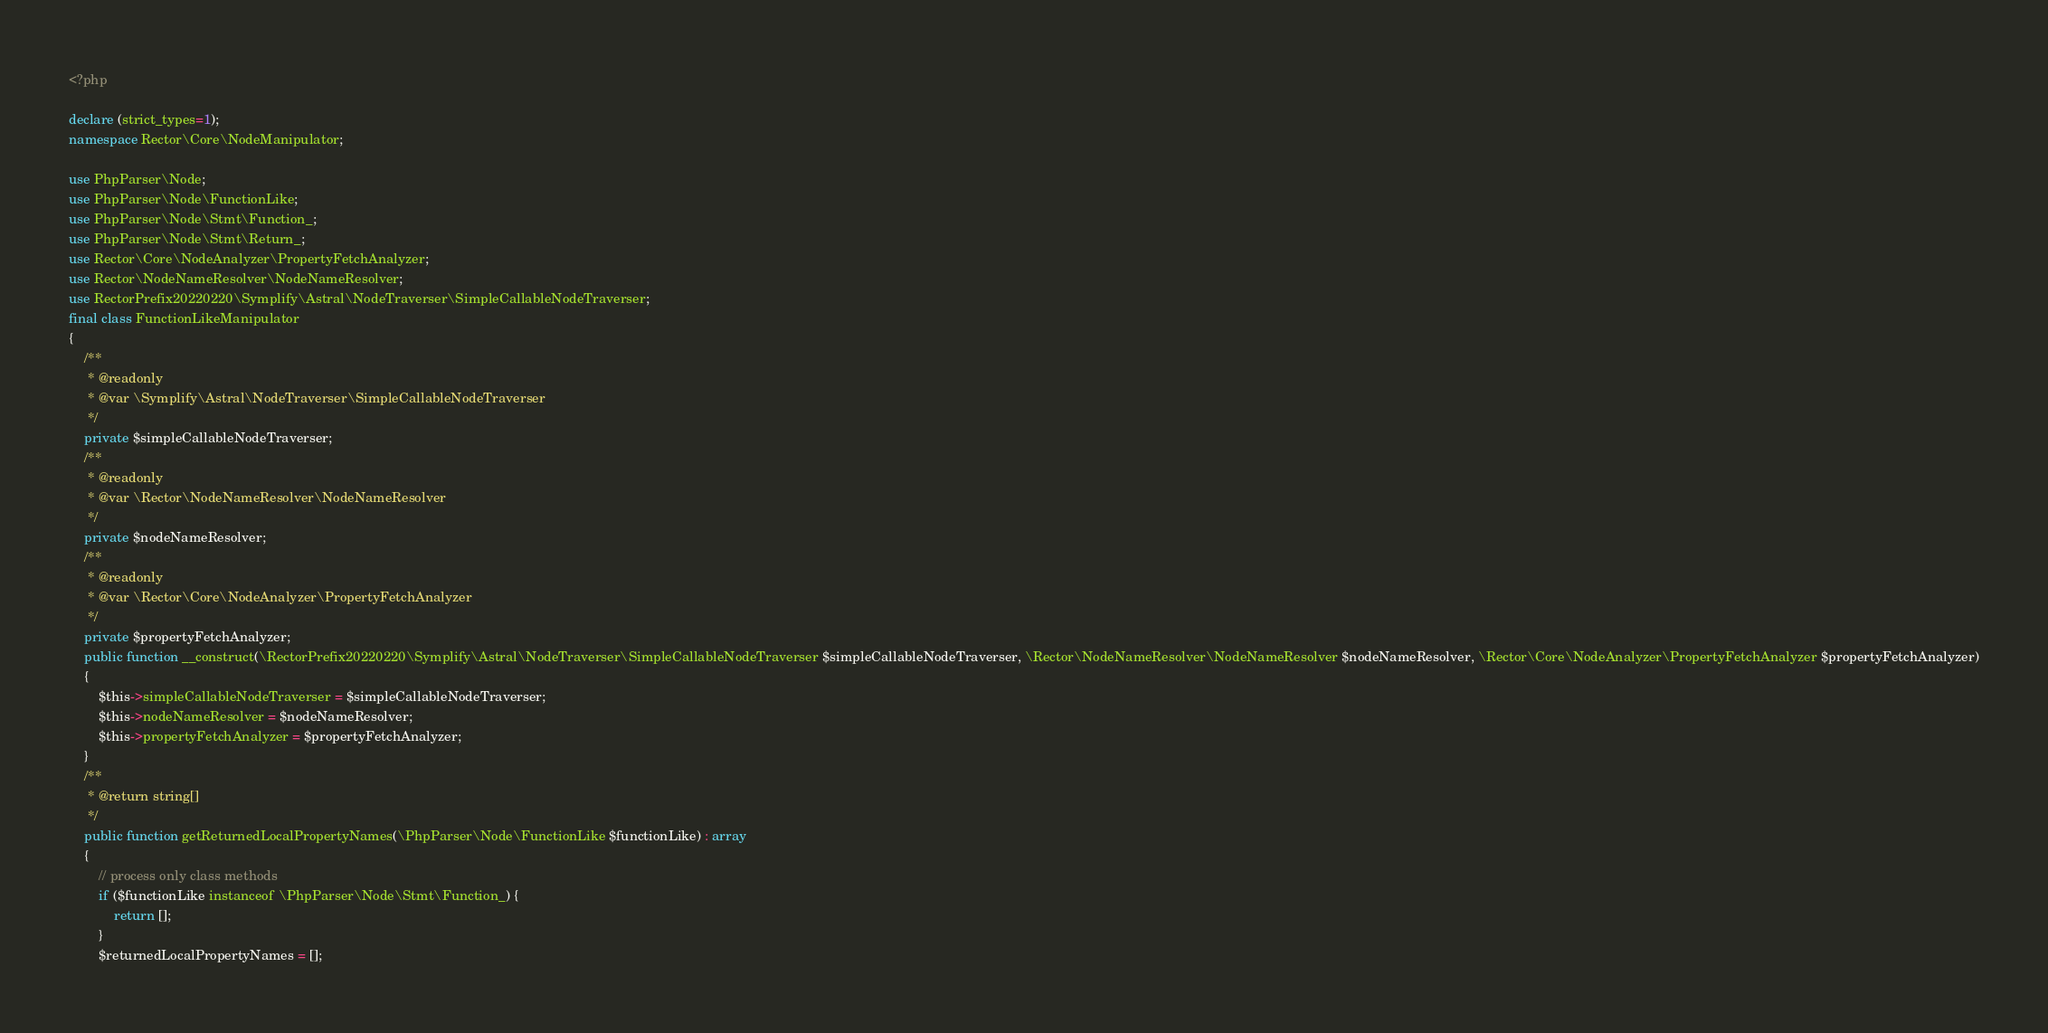Convert code to text. <code><loc_0><loc_0><loc_500><loc_500><_PHP_><?php

declare (strict_types=1);
namespace Rector\Core\NodeManipulator;

use PhpParser\Node;
use PhpParser\Node\FunctionLike;
use PhpParser\Node\Stmt\Function_;
use PhpParser\Node\Stmt\Return_;
use Rector\Core\NodeAnalyzer\PropertyFetchAnalyzer;
use Rector\NodeNameResolver\NodeNameResolver;
use RectorPrefix20220220\Symplify\Astral\NodeTraverser\SimpleCallableNodeTraverser;
final class FunctionLikeManipulator
{
    /**
     * @readonly
     * @var \Symplify\Astral\NodeTraverser\SimpleCallableNodeTraverser
     */
    private $simpleCallableNodeTraverser;
    /**
     * @readonly
     * @var \Rector\NodeNameResolver\NodeNameResolver
     */
    private $nodeNameResolver;
    /**
     * @readonly
     * @var \Rector\Core\NodeAnalyzer\PropertyFetchAnalyzer
     */
    private $propertyFetchAnalyzer;
    public function __construct(\RectorPrefix20220220\Symplify\Astral\NodeTraverser\SimpleCallableNodeTraverser $simpleCallableNodeTraverser, \Rector\NodeNameResolver\NodeNameResolver $nodeNameResolver, \Rector\Core\NodeAnalyzer\PropertyFetchAnalyzer $propertyFetchAnalyzer)
    {
        $this->simpleCallableNodeTraverser = $simpleCallableNodeTraverser;
        $this->nodeNameResolver = $nodeNameResolver;
        $this->propertyFetchAnalyzer = $propertyFetchAnalyzer;
    }
    /**
     * @return string[]
     */
    public function getReturnedLocalPropertyNames(\PhpParser\Node\FunctionLike $functionLike) : array
    {
        // process only class methods
        if ($functionLike instanceof \PhpParser\Node\Stmt\Function_) {
            return [];
        }
        $returnedLocalPropertyNames = [];</code> 